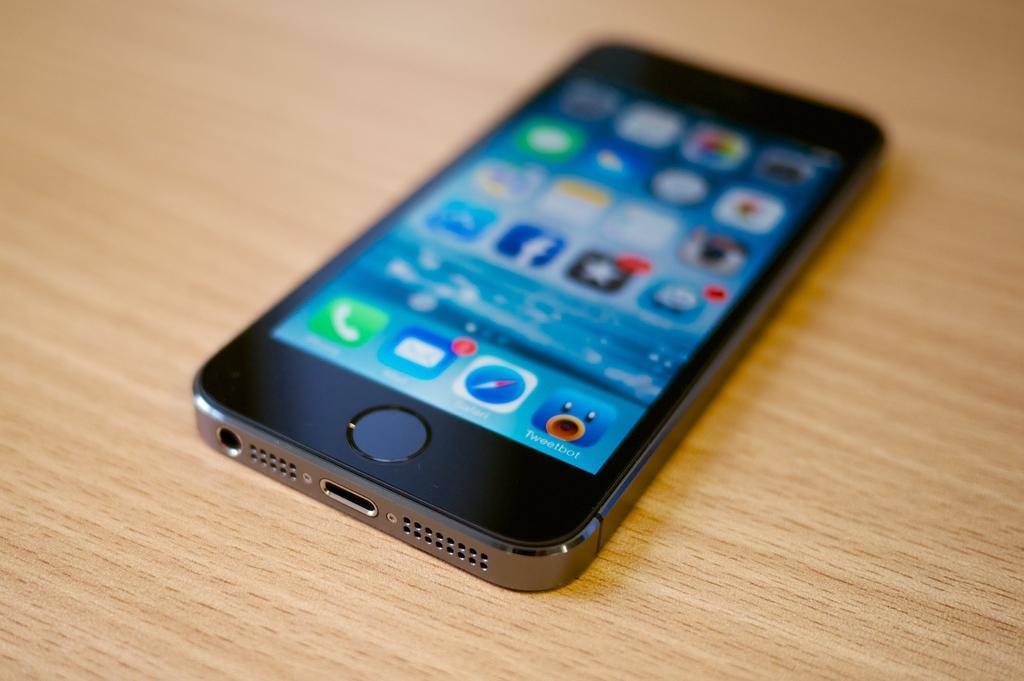What's the app with the blue duck face called?
Keep it short and to the point. Tweetbot. What is the app with the little envelope called?
Your response must be concise. Mail. 